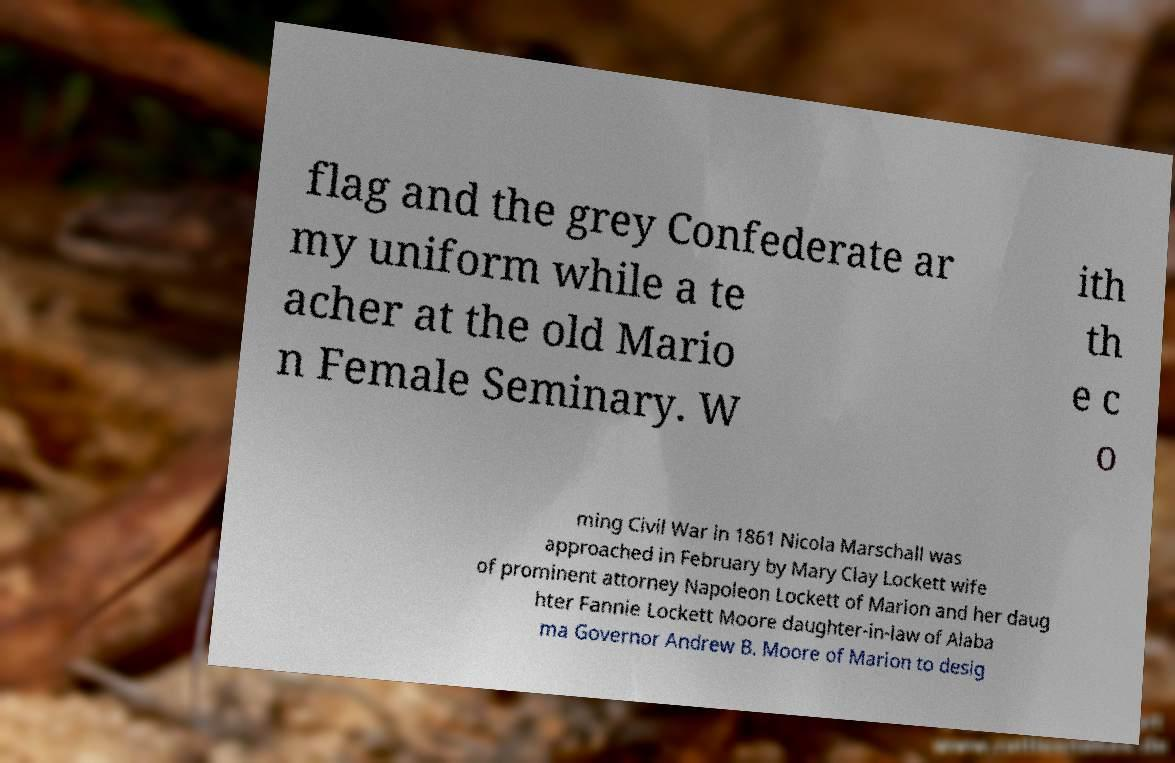Could you assist in decoding the text presented in this image and type it out clearly? flag and the grey Confederate ar my uniform while a te acher at the old Mario n Female Seminary. W ith th e c o ming Civil War in 1861 Nicola Marschall was approached in February by Mary Clay Lockett wife of prominent attorney Napoleon Lockett of Marion and her daug hter Fannie Lockett Moore daughter-in-law of Alaba ma Governor Andrew B. Moore of Marion to desig 